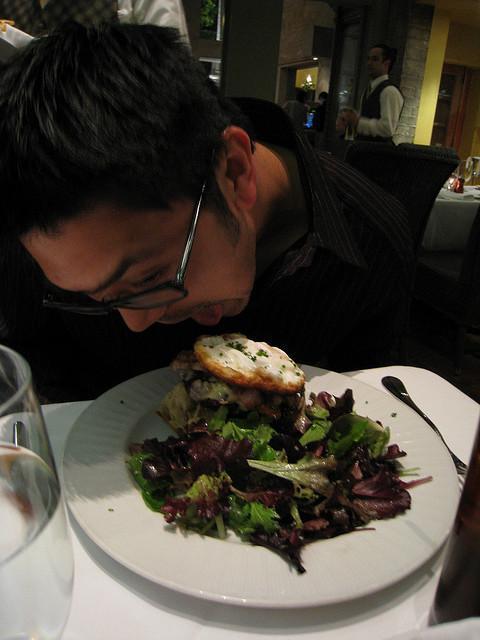How many people are there?
Give a very brief answer. 3. How many dining tables are there?
Give a very brief answer. 2. 